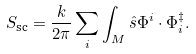<formula> <loc_0><loc_0><loc_500><loc_500>S _ { \text {sc} } = \frac { k } { 2 \pi } \sum _ { i } \int _ { M } \hat { s } \Phi ^ { i } \cdot \Phi _ { i } ^ { \ddag } .</formula> 